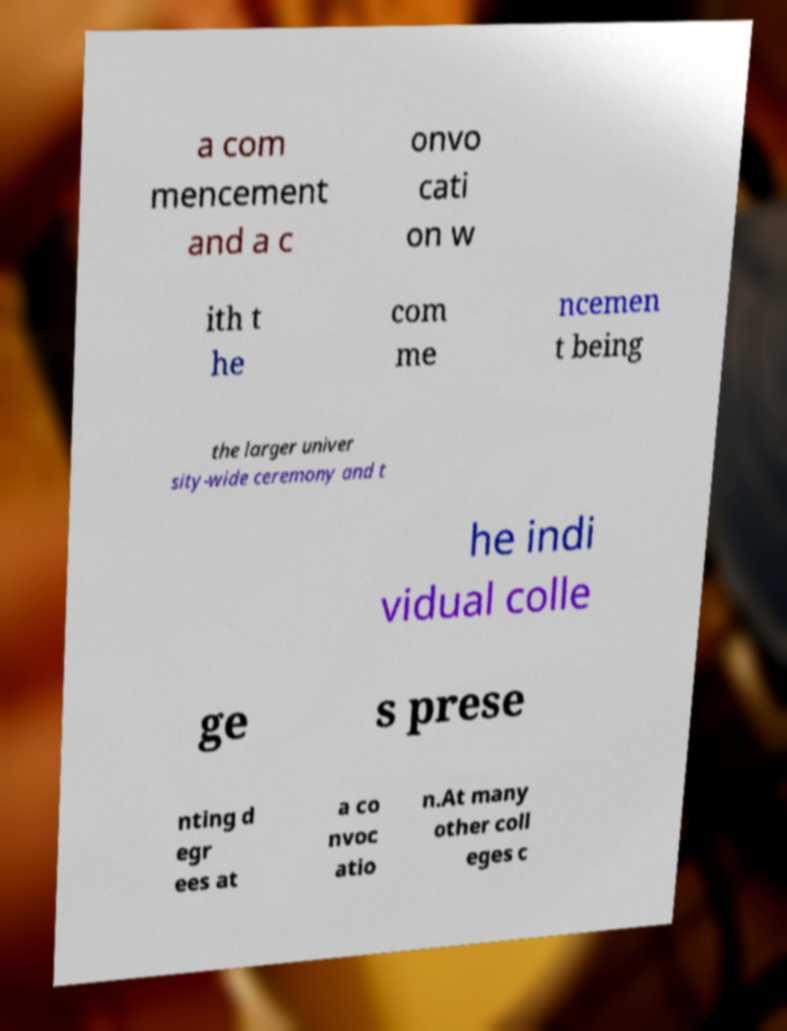There's text embedded in this image that I need extracted. Can you transcribe it verbatim? a com mencement and a c onvo cati on w ith t he com me ncemen t being the larger univer sity-wide ceremony and t he indi vidual colle ge s prese nting d egr ees at a co nvoc atio n.At many other coll eges c 